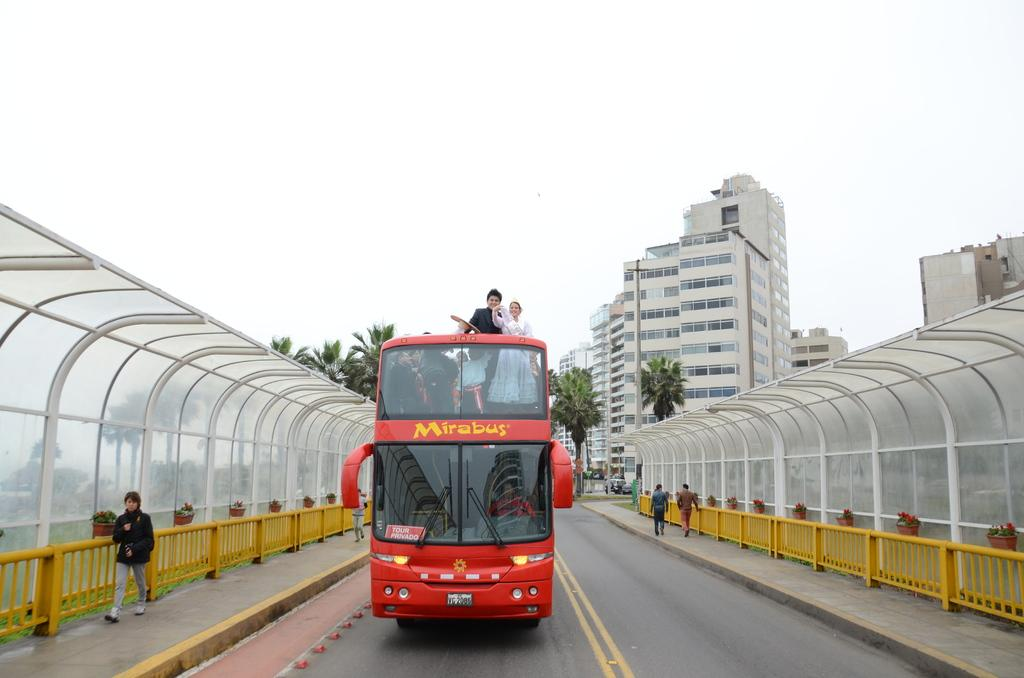<image>
Relay a brief, clear account of the picture shown. A red double decker bus with a yellow Mirabus logo on the front. 